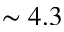Convert formula to latex. <formula><loc_0><loc_0><loc_500><loc_500>\sim 4 . 3</formula> 